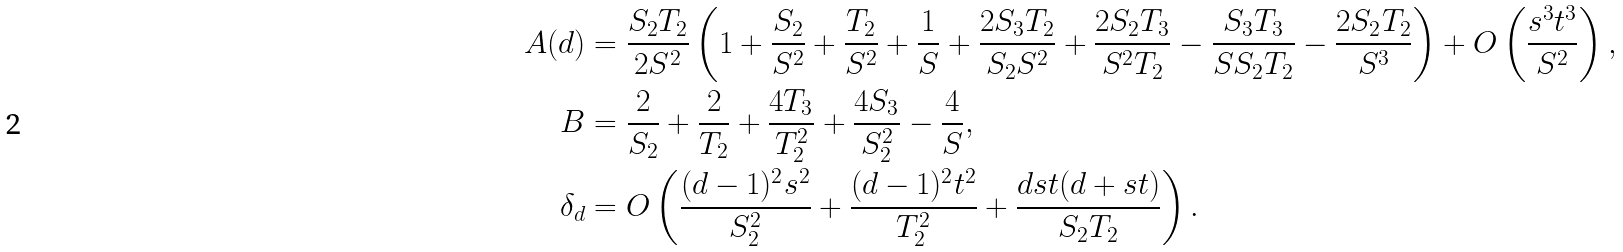<formula> <loc_0><loc_0><loc_500><loc_500>A ( d ) & = \frac { S _ { 2 } T _ { 2 } } { 2 S ^ { 2 } } \left ( 1 + \frac { S _ { 2 } } { S ^ { 2 } } + \frac { T _ { 2 } } { S ^ { 2 } } + \frac { 1 } { S } + \frac { 2 S _ { 3 } T _ { 2 } } { S _ { 2 } S ^ { 2 } } + \frac { 2 S _ { 2 } T _ { 3 } } { S ^ { 2 } T _ { 2 } } - \frac { S _ { 3 } T _ { 3 } } { S S _ { 2 } T _ { 2 } } - \frac { 2 S _ { 2 } T _ { 2 } } { S ^ { 3 } } \right ) + O \left ( \frac { s ^ { 3 } t ^ { 3 } } { S ^ { 2 } } \right ) , \\ B & = \frac { 2 } { S _ { 2 } } + \frac { 2 } { T _ { 2 } } + \frac { 4 T _ { 3 } } { T _ { 2 } ^ { 2 } } + \frac { 4 S _ { 3 } } { S _ { 2 } ^ { 2 } } - \frac { 4 } { S } , \\ \delta _ { d } & = O \left ( \frac { ( d - 1 ) ^ { 2 } s ^ { 2 } } { S _ { 2 } ^ { 2 } } + \frac { ( d - 1 ) ^ { 2 } t ^ { 2 } } { T _ { 2 } ^ { 2 } } + \frac { d s t ( d + s t ) } { S _ { 2 } T _ { 2 } } \right ) .</formula> 